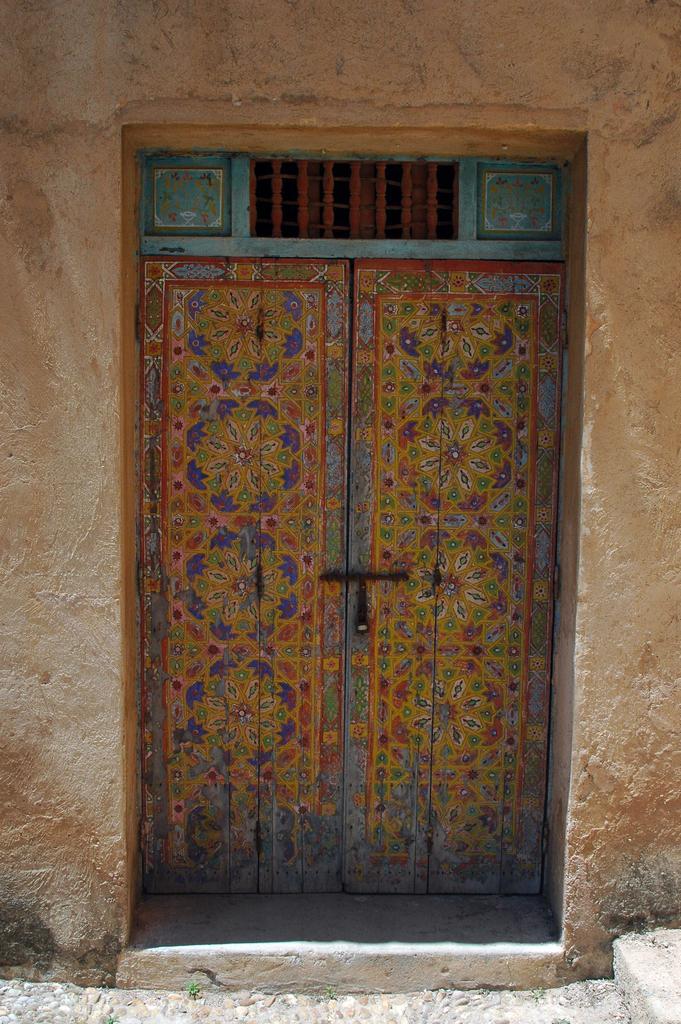Describe this image in one or two sentences. In the center of the image we can see a door of a building. 